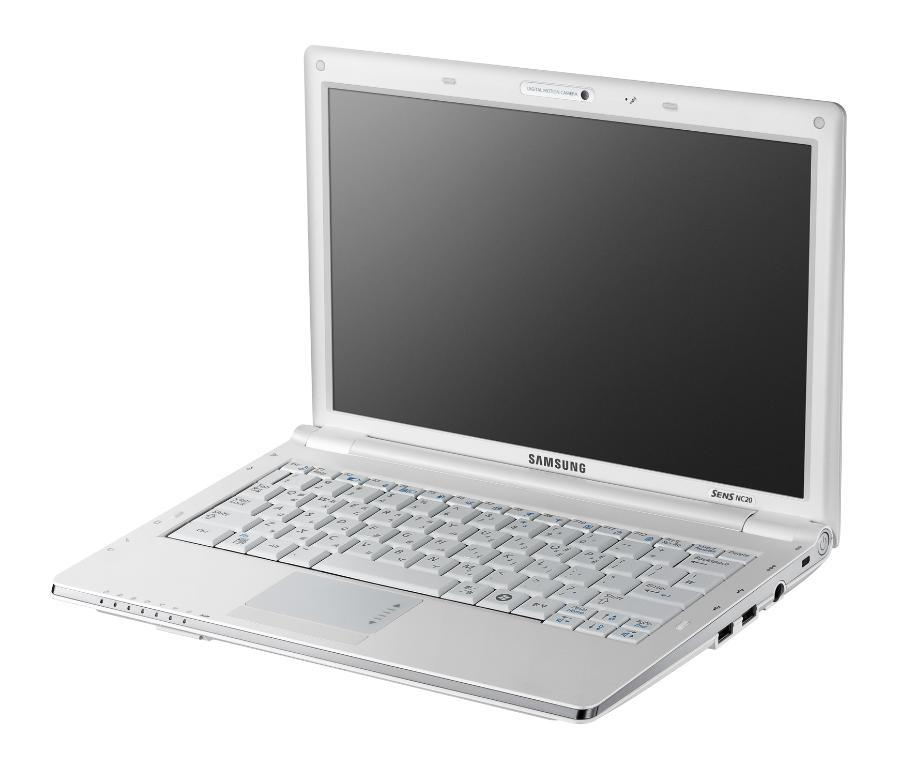<image>
Render a clear and concise summary of the photo. A Samsung laptop with a black screen in open. 